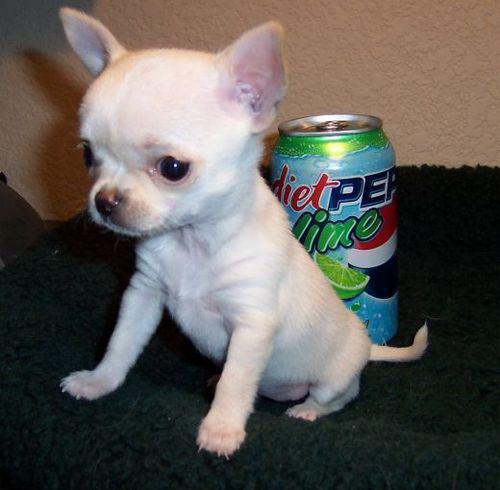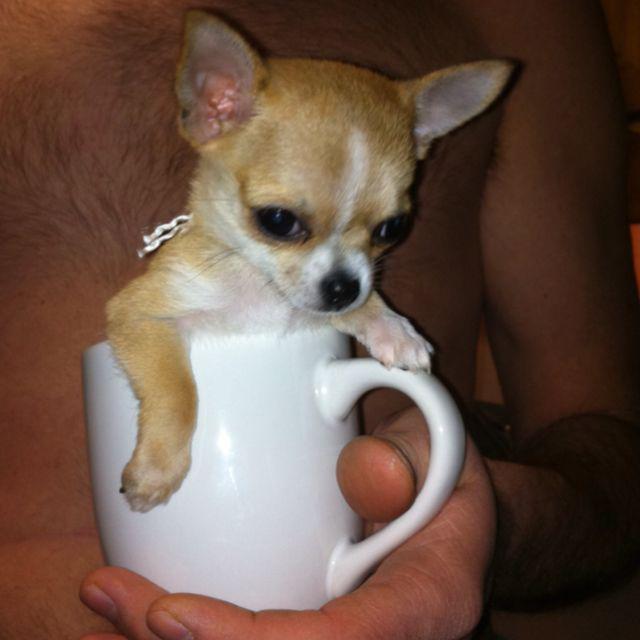The first image is the image on the left, the second image is the image on the right. Assess this claim about the two images: "A person is holding the dog in the image on the right.". Correct or not? Answer yes or no. Yes. The first image is the image on the left, the second image is the image on the right. Assess this claim about the two images: "The dog in the image on the right is being held by a human.". Correct or not? Answer yes or no. Yes. 